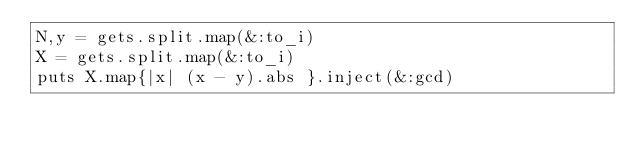<code> <loc_0><loc_0><loc_500><loc_500><_Ruby_>N,y = gets.split.map(&:to_i)
X = gets.split.map(&:to_i)
puts X.map{|x| (x - y).abs }.inject(&:gcd)</code> 